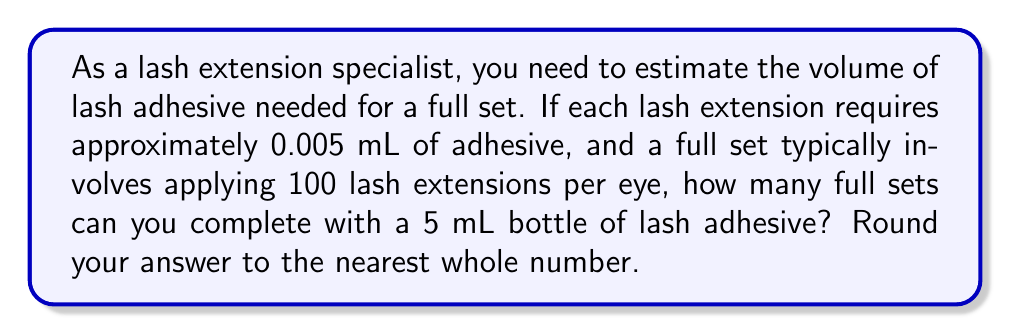Solve this math problem. To solve this problem, let's break it down into steps:

1. Calculate the total volume of adhesive needed for one full set:
   - Volume per lash = 0.005 mL
   - Number of lashes per eye = 100
   - Number of eyes = 2
   
   Total volume for one full set = $0.005 \text{ mL} \times 100 \times 2 = 1 \text{ mL}$

2. Calculate how many full sets can be completed with a 5 mL bottle:
   $$\text{Number of full sets} = \frac{\text{Total volume in bottle}}{\text{Volume needed for one full set}}$$
   $$\text{Number of full sets} = \frac{5 \text{ mL}}{1 \text{ mL}} = 5$$

3. Since we need to round to the nearest whole number, and the result is already a whole number, no further rounding is necessary.

Therefore, with a 5 mL bottle of lash adhesive, you can complete 5 full sets of lash extensions.
Answer: 5 full sets 